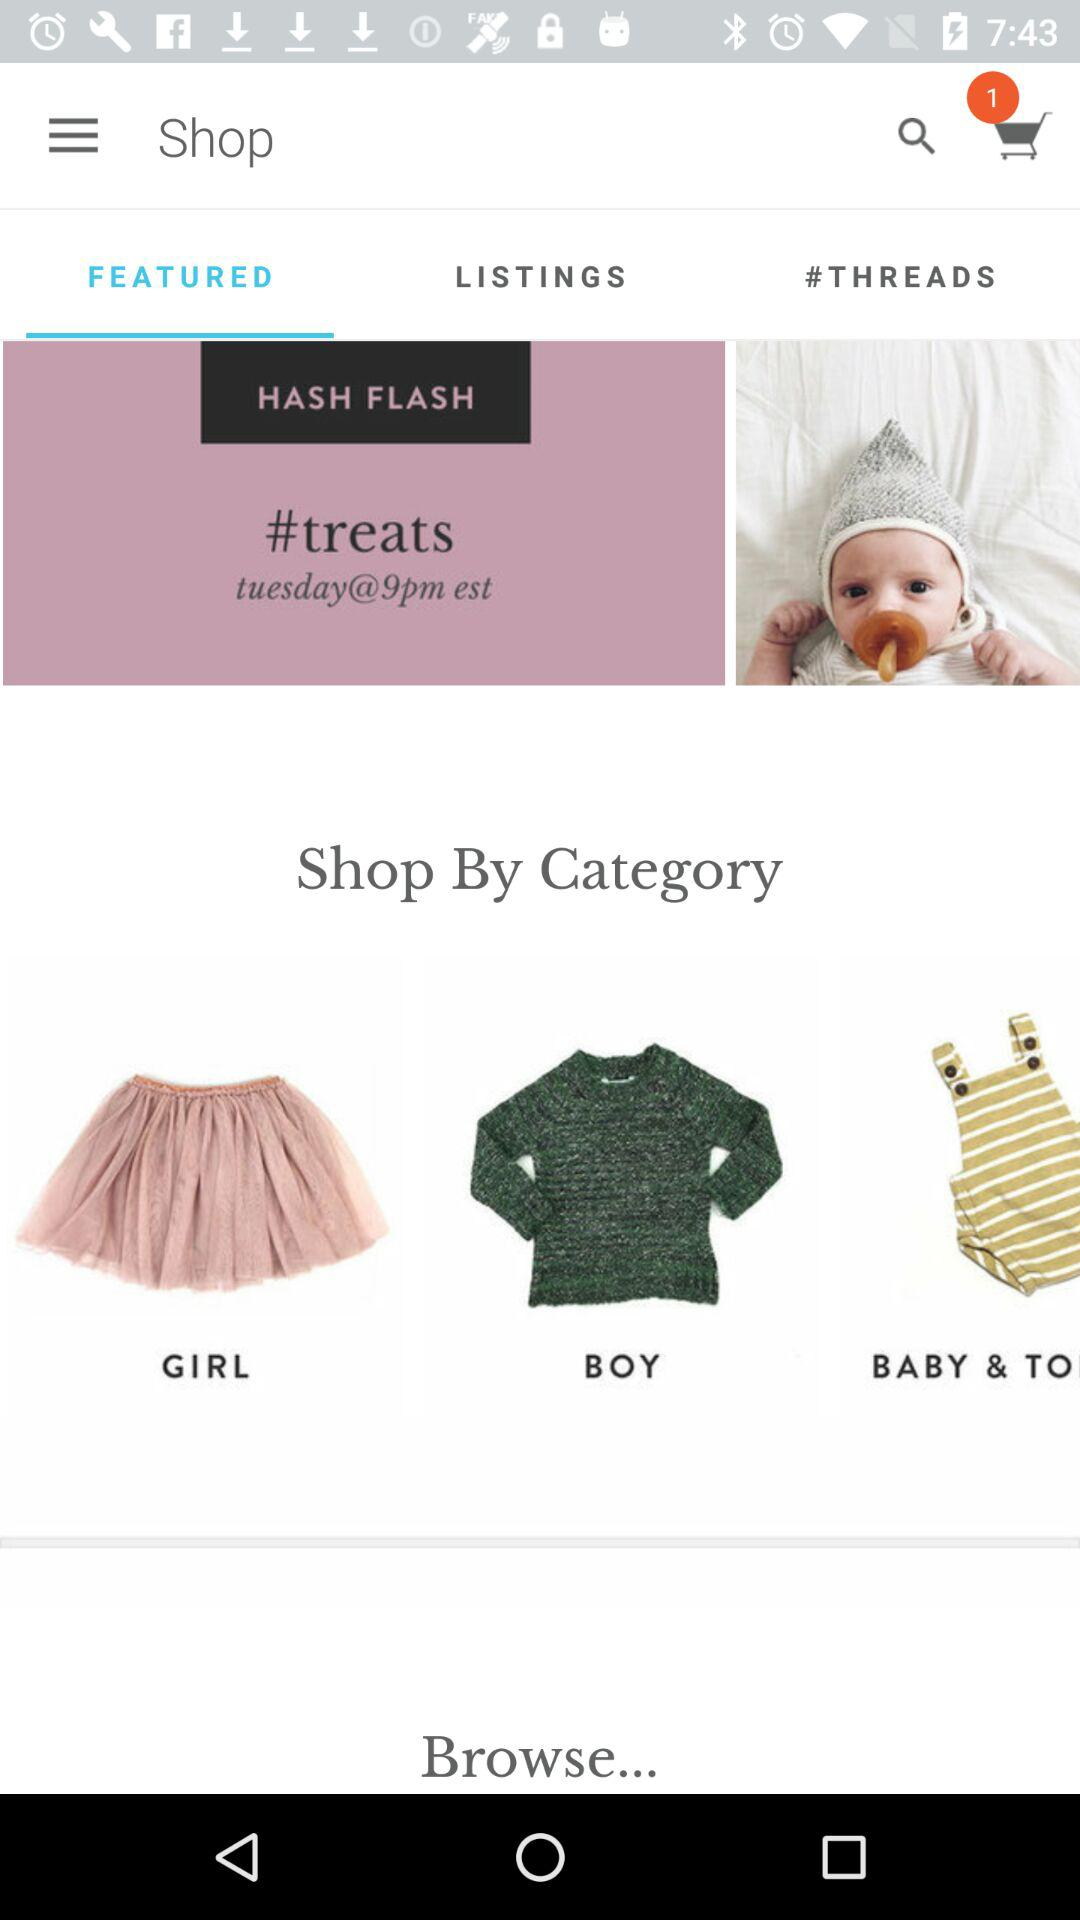Which option is selected in "Shop"? The selected option is "FEATURED". 